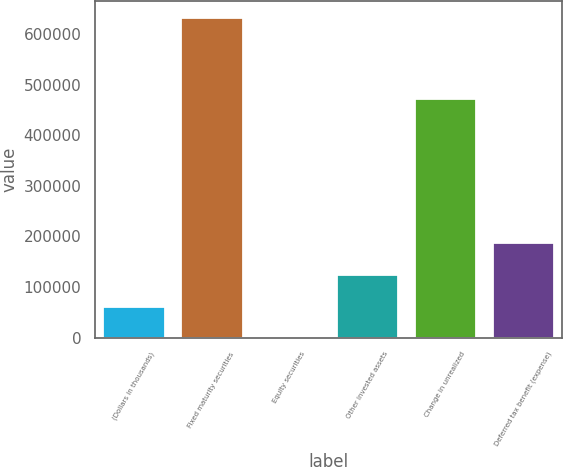<chart> <loc_0><loc_0><loc_500><loc_500><bar_chart><fcel>(Dollars in thousands)<fcel>Fixed maturity securities<fcel>Equity securities<fcel>Other invested assets<fcel>Change in unrealized<fcel>Deferred tax benefit (expense)<nl><fcel>63244.2<fcel>633949<fcel>346<fcel>126142<fcel>472633<fcel>189041<nl></chart> 